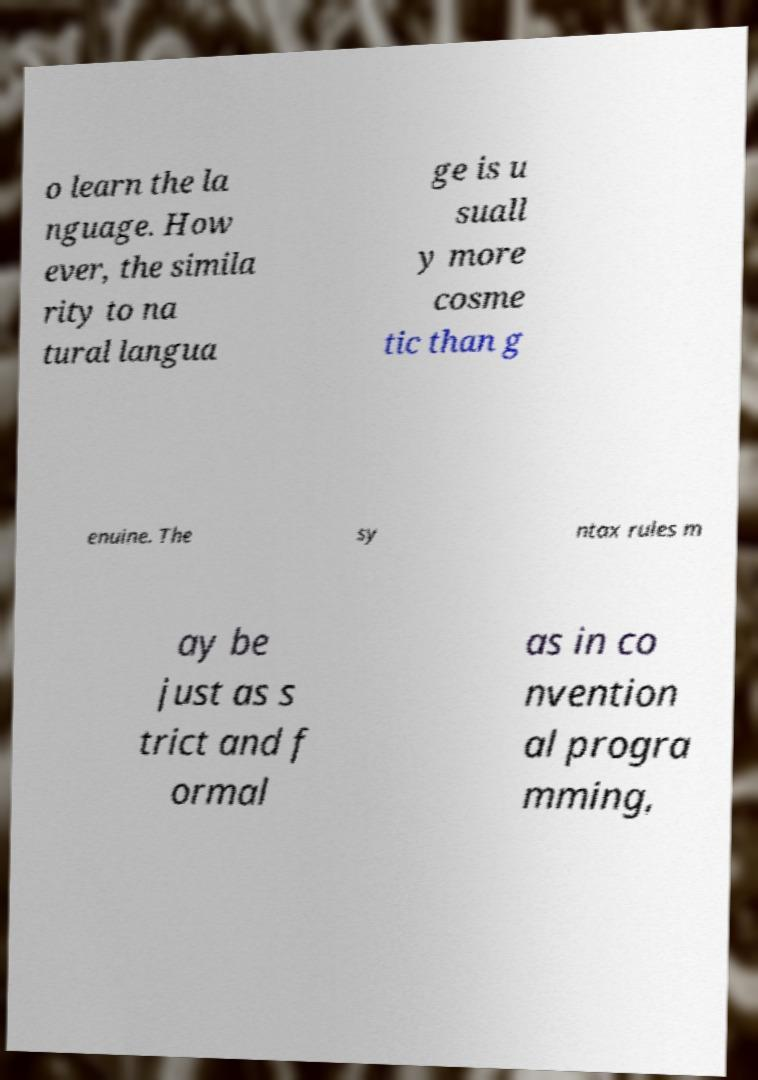For documentation purposes, I need the text within this image transcribed. Could you provide that? o learn the la nguage. How ever, the simila rity to na tural langua ge is u suall y more cosme tic than g enuine. The sy ntax rules m ay be just as s trict and f ormal as in co nvention al progra mming, 